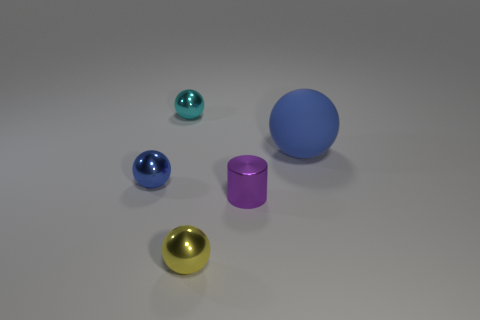Is the color of the object that is right of the purple shiny object the same as the metallic thing that is to the left of the cyan shiny ball?
Your answer should be compact. Yes. The thing that is to the left of the shiny sphere behind the big sphere is what shape?
Your answer should be very brief. Sphere. There is a blue sphere on the right side of the tiny sphere that is behind the matte thing; what is its size?
Make the answer very short. Large. What is the color of the metal object in front of the purple cylinder?
Keep it short and to the point. Yellow. How many other small blue things are the same shape as the small blue thing?
Your answer should be very brief. 0. Are there any small blue things that have the same material as the small cylinder?
Your answer should be very brief. Yes. There is a tiny sphere that is both behind the yellow thing and to the right of the blue metallic object; what is its color?
Your answer should be compact. Cyan. How many other things are there of the same color as the large thing?
Your response must be concise. 1. There is a tiny ball that is to the left of the small thing behind the blue object left of the small purple object; what is its material?
Ensure brevity in your answer.  Metal. What number of spheres are large gray metal things or tiny blue things?
Make the answer very short. 1. 